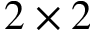Convert formula to latex. <formula><loc_0><loc_0><loc_500><loc_500>2 \times 2</formula> 